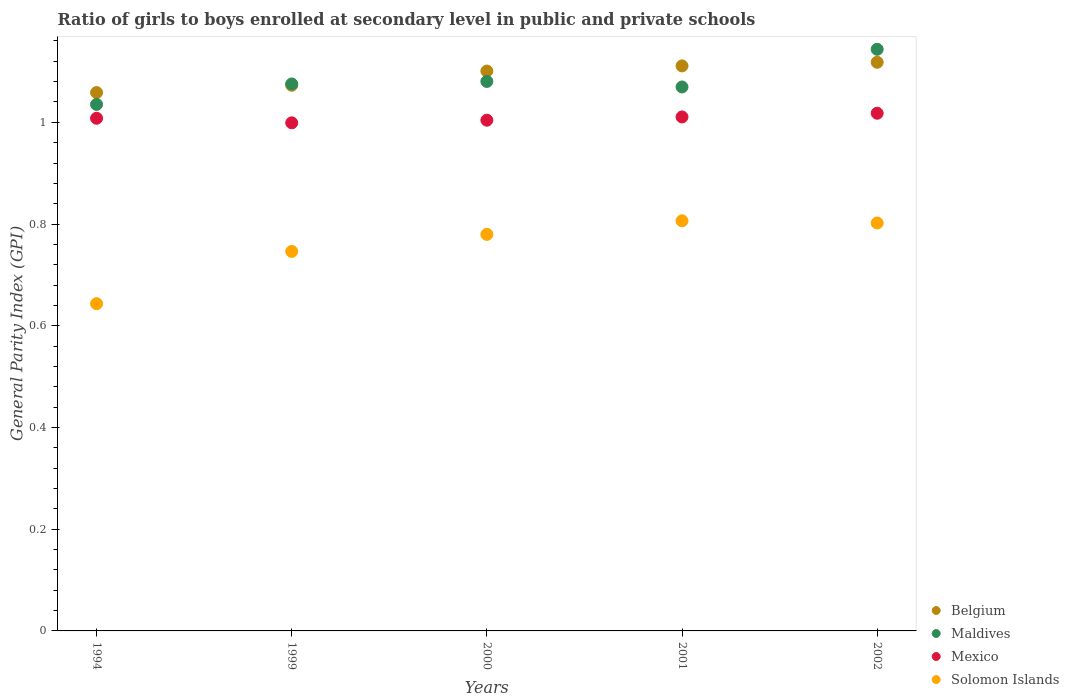Is the number of dotlines equal to the number of legend labels?
Your response must be concise. Yes. Across all years, what is the maximum general parity index in Mexico?
Offer a very short reply. 1.02. Across all years, what is the minimum general parity index in Maldives?
Provide a succinct answer. 1.04. In which year was the general parity index in Mexico maximum?
Provide a short and direct response. 2002. In which year was the general parity index in Solomon Islands minimum?
Make the answer very short. 1994. What is the total general parity index in Maldives in the graph?
Offer a very short reply. 5.4. What is the difference between the general parity index in Solomon Islands in 1994 and that in 2002?
Keep it short and to the point. -0.16. What is the difference between the general parity index in Belgium in 2002 and the general parity index in Mexico in 1999?
Make the answer very short. 0.12. What is the average general parity index in Belgium per year?
Ensure brevity in your answer.  1.09. In the year 2002, what is the difference between the general parity index in Belgium and general parity index in Solomon Islands?
Your response must be concise. 0.32. What is the ratio of the general parity index in Solomon Islands in 1999 to that in 2001?
Keep it short and to the point. 0.93. What is the difference between the highest and the second highest general parity index in Belgium?
Keep it short and to the point. 0.01. What is the difference between the highest and the lowest general parity index in Mexico?
Make the answer very short. 0.02. Is it the case that in every year, the sum of the general parity index in Mexico and general parity index in Maldives  is greater than the sum of general parity index in Solomon Islands and general parity index in Belgium?
Provide a succinct answer. Yes. Is the general parity index in Mexico strictly less than the general parity index in Belgium over the years?
Provide a succinct answer. Yes. How many years are there in the graph?
Offer a very short reply. 5. What is the difference between two consecutive major ticks on the Y-axis?
Your answer should be very brief. 0.2. Are the values on the major ticks of Y-axis written in scientific E-notation?
Ensure brevity in your answer.  No. Does the graph contain any zero values?
Ensure brevity in your answer.  No. Does the graph contain grids?
Offer a terse response. No. Where does the legend appear in the graph?
Offer a terse response. Bottom right. How many legend labels are there?
Your answer should be very brief. 4. How are the legend labels stacked?
Your response must be concise. Vertical. What is the title of the graph?
Keep it short and to the point. Ratio of girls to boys enrolled at secondary level in public and private schools. Does "Ecuador" appear as one of the legend labels in the graph?
Offer a very short reply. No. What is the label or title of the X-axis?
Give a very brief answer. Years. What is the label or title of the Y-axis?
Provide a succinct answer. General Parity Index (GPI). What is the General Parity Index (GPI) of Belgium in 1994?
Give a very brief answer. 1.06. What is the General Parity Index (GPI) in Maldives in 1994?
Offer a very short reply. 1.04. What is the General Parity Index (GPI) of Solomon Islands in 1994?
Offer a very short reply. 0.64. What is the General Parity Index (GPI) in Belgium in 1999?
Give a very brief answer. 1.07. What is the General Parity Index (GPI) of Maldives in 1999?
Provide a short and direct response. 1.08. What is the General Parity Index (GPI) in Mexico in 1999?
Ensure brevity in your answer.  1. What is the General Parity Index (GPI) of Solomon Islands in 1999?
Provide a succinct answer. 0.75. What is the General Parity Index (GPI) of Belgium in 2000?
Offer a very short reply. 1.1. What is the General Parity Index (GPI) of Maldives in 2000?
Your response must be concise. 1.08. What is the General Parity Index (GPI) of Mexico in 2000?
Provide a succinct answer. 1. What is the General Parity Index (GPI) in Solomon Islands in 2000?
Provide a short and direct response. 0.78. What is the General Parity Index (GPI) of Belgium in 2001?
Offer a very short reply. 1.11. What is the General Parity Index (GPI) in Maldives in 2001?
Your response must be concise. 1.07. What is the General Parity Index (GPI) in Mexico in 2001?
Your answer should be compact. 1.01. What is the General Parity Index (GPI) in Solomon Islands in 2001?
Make the answer very short. 0.81. What is the General Parity Index (GPI) in Belgium in 2002?
Provide a succinct answer. 1.12. What is the General Parity Index (GPI) in Maldives in 2002?
Your answer should be very brief. 1.14. What is the General Parity Index (GPI) of Mexico in 2002?
Provide a short and direct response. 1.02. What is the General Parity Index (GPI) in Solomon Islands in 2002?
Offer a very short reply. 0.8. Across all years, what is the maximum General Parity Index (GPI) in Belgium?
Your answer should be very brief. 1.12. Across all years, what is the maximum General Parity Index (GPI) of Maldives?
Offer a terse response. 1.14. Across all years, what is the maximum General Parity Index (GPI) in Mexico?
Provide a succinct answer. 1.02. Across all years, what is the maximum General Parity Index (GPI) of Solomon Islands?
Make the answer very short. 0.81. Across all years, what is the minimum General Parity Index (GPI) in Belgium?
Provide a short and direct response. 1.06. Across all years, what is the minimum General Parity Index (GPI) of Maldives?
Give a very brief answer. 1.04. Across all years, what is the minimum General Parity Index (GPI) in Mexico?
Offer a terse response. 1. Across all years, what is the minimum General Parity Index (GPI) of Solomon Islands?
Keep it short and to the point. 0.64. What is the total General Parity Index (GPI) in Belgium in the graph?
Keep it short and to the point. 5.46. What is the total General Parity Index (GPI) in Maldives in the graph?
Keep it short and to the point. 5.4. What is the total General Parity Index (GPI) of Mexico in the graph?
Give a very brief answer. 5.04. What is the total General Parity Index (GPI) of Solomon Islands in the graph?
Provide a short and direct response. 3.78. What is the difference between the General Parity Index (GPI) of Belgium in 1994 and that in 1999?
Your response must be concise. -0.01. What is the difference between the General Parity Index (GPI) of Maldives in 1994 and that in 1999?
Provide a short and direct response. -0.04. What is the difference between the General Parity Index (GPI) of Mexico in 1994 and that in 1999?
Your answer should be very brief. 0.01. What is the difference between the General Parity Index (GPI) of Solomon Islands in 1994 and that in 1999?
Keep it short and to the point. -0.1. What is the difference between the General Parity Index (GPI) of Belgium in 1994 and that in 2000?
Give a very brief answer. -0.04. What is the difference between the General Parity Index (GPI) in Maldives in 1994 and that in 2000?
Provide a succinct answer. -0.05. What is the difference between the General Parity Index (GPI) in Mexico in 1994 and that in 2000?
Offer a very short reply. 0. What is the difference between the General Parity Index (GPI) of Solomon Islands in 1994 and that in 2000?
Keep it short and to the point. -0.14. What is the difference between the General Parity Index (GPI) of Belgium in 1994 and that in 2001?
Keep it short and to the point. -0.05. What is the difference between the General Parity Index (GPI) of Maldives in 1994 and that in 2001?
Give a very brief answer. -0.03. What is the difference between the General Parity Index (GPI) in Mexico in 1994 and that in 2001?
Offer a very short reply. -0. What is the difference between the General Parity Index (GPI) of Solomon Islands in 1994 and that in 2001?
Offer a very short reply. -0.16. What is the difference between the General Parity Index (GPI) in Belgium in 1994 and that in 2002?
Your response must be concise. -0.06. What is the difference between the General Parity Index (GPI) in Maldives in 1994 and that in 2002?
Provide a succinct answer. -0.11. What is the difference between the General Parity Index (GPI) of Mexico in 1994 and that in 2002?
Your answer should be very brief. -0.01. What is the difference between the General Parity Index (GPI) in Solomon Islands in 1994 and that in 2002?
Make the answer very short. -0.16. What is the difference between the General Parity Index (GPI) of Belgium in 1999 and that in 2000?
Your answer should be compact. -0.03. What is the difference between the General Parity Index (GPI) in Maldives in 1999 and that in 2000?
Offer a very short reply. -0. What is the difference between the General Parity Index (GPI) in Mexico in 1999 and that in 2000?
Offer a very short reply. -0.01. What is the difference between the General Parity Index (GPI) in Solomon Islands in 1999 and that in 2000?
Make the answer very short. -0.03. What is the difference between the General Parity Index (GPI) in Belgium in 1999 and that in 2001?
Give a very brief answer. -0.04. What is the difference between the General Parity Index (GPI) in Maldives in 1999 and that in 2001?
Make the answer very short. 0.01. What is the difference between the General Parity Index (GPI) in Mexico in 1999 and that in 2001?
Provide a short and direct response. -0.01. What is the difference between the General Parity Index (GPI) of Solomon Islands in 1999 and that in 2001?
Ensure brevity in your answer.  -0.06. What is the difference between the General Parity Index (GPI) in Belgium in 1999 and that in 2002?
Provide a succinct answer. -0.05. What is the difference between the General Parity Index (GPI) of Maldives in 1999 and that in 2002?
Offer a very short reply. -0.07. What is the difference between the General Parity Index (GPI) in Mexico in 1999 and that in 2002?
Provide a succinct answer. -0.02. What is the difference between the General Parity Index (GPI) in Solomon Islands in 1999 and that in 2002?
Offer a terse response. -0.06. What is the difference between the General Parity Index (GPI) of Belgium in 2000 and that in 2001?
Offer a very short reply. -0.01. What is the difference between the General Parity Index (GPI) of Maldives in 2000 and that in 2001?
Offer a very short reply. 0.01. What is the difference between the General Parity Index (GPI) in Mexico in 2000 and that in 2001?
Provide a short and direct response. -0.01. What is the difference between the General Parity Index (GPI) in Solomon Islands in 2000 and that in 2001?
Your response must be concise. -0.03. What is the difference between the General Parity Index (GPI) of Belgium in 2000 and that in 2002?
Your answer should be very brief. -0.02. What is the difference between the General Parity Index (GPI) of Maldives in 2000 and that in 2002?
Keep it short and to the point. -0.06. What is the difference between the General Parity Index (GPI) in Mexico in 2000 and that in 2002?
Provide a succinct answer. -0.01. What is the difference between the General Parity Index (GPI) in Solomon Islands in 2000 and that in 2002?
Offer a terse response. -0.02. What is the difference between the General Parity Index (GPI) of Belgium in 2001 and that in 2002?
Give a very brief answer. -0.01. What is the difference between the General Parity Index (GPI) of Maldives in 2001 and that in 2002?
Provide a short and direct response. -0.07. What is the difference between the General Parity Index (GPI) in Mexico in 2001 and that in 2002?
Provide a succinct answer. -0.01. What is the difference between the General Parity Index (GPI) in Solomon Islands in 2001 and that in 2002?
Offer a terse response. 0. What is the difference between the General Parity Index (GPI) of Belgium in 1994 and the General Parity Index (GPI) of Maldives in 1999?
Ensure brevity in your answer.  -0.02. What is the difference between the General Parity Index (GPI) in Belgium in 1994 and the General Parity Index (GPI) in Mexico in 1999?
Keep it short and to the point. 0.06. What is the difference between the General Parity Index (GPI) of Belgium in 1994 and the General Parity Index (GPI) of Solomon Islands in 1999?
Provide a short and direct response. 0.31. What is the difference between the General Parity Index (GPI) in Maldives in 1994 and the General Parity Index (GPI) in Mexico in 1999?
Provide a short and direct response. 0.04. What is the difference between the General Parity Index (GPI) in Maldives in 1994 and the General Parity Index (GPI) in Solomon Islands in 1999?
Your answer should be very brief. 0.29. What is the difference between the General Parity Index (GPI) in Mexico in 1994 and the General Parity Index (GPI) in Solomon Islands in 1999?
Your answer should be very brief. 0.26. What is the difference between the General Parity Index (GPI) in Belgium in 1994 and the General Parity Index (GPI) in Maldives in 2000?
Your answer should be compact. -0.02. What is the difference between the General Parity Index (GPI) of Belgium in 1994 and the General Parity Index (GPI) of Mexico in 2000?
Provide a short and direct response. 0.05. What is the difference between the General Parity Index (GPI) in Belgium in 1994 and the General Parity Index (GPI) in Solomon Islands in 2000?
Ensure brevity in your answer.  0.28. What is the difference between the General Parity Index (GPI) in Maldives in 1994 and the General Parity Index (GPI) in Mexico in 2000?
Your answer should be compact. 0.03. What is the difference between the General Parity Index (GPI) of Maldives in 1994 and the General Parity Index (GPI) of Solomon Islands in 2000?
Keep it short and to the point. 0.26. What is the difference between the General Parity Index (GPI) of Mexico in 1994 and the General Parity Index (GPI) of Solomon Islands in 2000?
Offer a very short reply. 0.23. What is the difference between the General Parity Index (GPI) of Belgium in 1994 and the General Parity Index (GPI) of Maldives in 2001?
Give a very brief answer. -0.01. What is the difference between the General Parity Index (GPI) of Belgium in 1994 and the General Parity Index (GPI) of Mexico in 2001?
Your answer should be very brief. 0.05. What is the difference between the General Parity Index (GPI) in Belgium in 1994 and the General Parity Index (GPI) in Solomon Islands in 2001?
Your answer should be compact. 0.25. What is the difference between the General Parity Index (GPI) in Maldives in 1994 and the General Parity Index (GPI) in Mexico in 2001?
Your answer should be compact. 0.02. What is the difference between the General Parity Index (GPI) in Maldives in 1994 and the General Parity Index (GPI) in Solomon Islands in 2001?
Provide a succinct answer. 0.23. What is the difference between the General Parity Index (GPI) in Mexico in 1994 and the General Parity Index (GPI) in Solomon Islands in 2001?
Your answer should be compact. 0.2. What is the difference between the General Parity Index (GPI) in Belgium in 1994 and the General Parity Index (GPI) in Maldives in 2002?
Ensure brevity in your answer.  -0.09. What is the difference between the General Parity Index (GPI) of Belgium in 1994 and the General Parity Index (GPI) of Mexico in 2002?
Keep it short and to the point. 0.04. What is the difference between the General Parity Index (GPI) in Belgium in 1994 and the General Parity Index (GPI) in Solomon Islands in 2002?
Keep it short and to the point. 0.26. What is the difference between the General Parity Index (GPI) in Maldives in 1994 and the General Parity Index (GPI) in Mexico in 2002?
Offer a terse response. 0.02. What is the difference between the General Parity Index (GPI) in Maldives in 1994 and the General Parity Index (GPI) in Solomon Islands in 2002?
Your answer should be compact. 0.23. What is the difference between the General Parity Index (GPI) in Mexico in 1994 and the General Parity Index (GPI) in Solomon Islands in 2002?
Provide a succinct answer. 0.21. What is the difference between the General Parity Index (GPI) in Belgium in 1999 and the General Parity Index (GPI) in Maldives in 2000?
Provide a succinct answer. -0.01. What is the difference between the General Parity Index (GPI) of Belgium in 1999 and the General Parity Index (GPI) of Mexico in 2000?
Offer a very short reply. 0.07. What is the difference between the General Parity Index (GPI) of Belgium in 1999 and the General Parity Index (GPI) of Solomon Islands in 2000?
Your response must be concise. 0.29. What is the difference between the General Parity Index (GPI) of Maldives in 1999 and the General Parity Index (GPI) of Mexico in 2000?
Your answer should be very brief. 0.07. What is the difference between the General Parity Index (GPI) of Maldives in 1999 and the General Parity Index (GPI) of Solomon Islands in 2000?
Give a very brief answer. 0.3. What is the difference between the General Parity Index (GPI) of Mexico in 1999 and the General Parity Index (GPI) of Solomon Islands in 2000?
Make the answer very short. 0.22. What is the difference between the General Parity Index (GPI) of Belgium in 1999 and the General Parity Index (GPI) of Maldives in 2001?
Keep it short and to the point. 0. What is the difference between the General Parity Index (GPI) of Belgium in 1999 and the General Parity Index (GPI) of Mexico in 2001?
Keep it short and to the point. 0.06. What is the difference between the General Parity Index (GPI) in Belgium in 1999 and the General Parity Index (GPI) in Solomon Islands in 2001?
Your answer should be very brief. 0.27. What is the difference between the General Parity Index (GPI) in Maldives in 1999 and the General Parity Index (GPI) in Mexico in 2001?
Provide a short and direct response. 0.06. What is the difference between the General Parity Index (GPI) in Maldives in 1999 and the General Parity Index (GPI) in Solomon Islands in 2001?
Offer a terse response. 0.27. What is the difference between the General Parity Index (GPI) of Mexico in 1999 and the General Parity Index (GPI) of Solomon Islands in 2001?
Your answer should be very brief. 0.19. What is the difference between the General Parity Index (GPI) of Belgium in 1999 and the General Parity Index (GPI) of Maldives in 2002?
Your response must be concise. -0.07. What is the difference between the General Parity Index (GPI) of Belgium in 1999 and the General Parity Index (GPI) of Mexico in 2002?
Give a very brief answer. 0.06. What is the difference between the General Parity Index (GPI) in Belgium in 1999 and the General Parity Index (GPI) in Solomon Islands in 2002?
Your response must be concise. 0.27. What is the difference between the General Parity Index (GPI) in Maldives in 1999 and the General Parity Index (GPI) in Mexico in 2002?
Give a very brief answer. 0.06. What is the difference between the General Parity Index (GPI) of Maldives in 1999 and the General Parity Index (GPI) of Solomon Islands in 2002?
Ensure brevity in your answer.  0.27. What is the difference between the General Parity Index (GPI) in Mexico in 1999 and the General Parity Index (GPI) in Solomon Islands in 2002?
Ensure brevity in your answer.  0.2. What is the difference between the General Parity Index (GPI) of Belgium in 2000 and the General Parity Index (GPI) of Maldives in 2001?
Your answer should be compact. 0.03. What is the difference between the General Parity Index (GPI) in Belgium in 2000 and the General Parity Index (GPI) in Mexico in 2001?
Ensure brevity in your answer.  0.09. What is the difference between the General Parity Index (GPI) in Belgium in 2000 and the General Parity Index (GPI) in Solomon Islands in 2001?
Provide a succinct answer. 0.29. What is the difference between the General Parity Index (GPI) in Maldives in 2000 and the General Parity Index (GPI) in Mexico in 2001?
Your answer should be very brief. 0.07. What is the difference between the General Parity Index (GPI) of Maldives in 2000 and the General Parity Index (GPI) of Solomon Islands in 2001?
Provide a succinct answer. 0.27. What is the difference between the General Parity Index (GPI) in Mexico in 2000 and the General Parity Index (GPI) in Solomon Islands in 2001?
Make the answer very short. 0.2. What is the difference between the General Parity Index (GPI) of Belgium in 2000 and the General Parity Index (GPI) of Maldives in 2002?
Offer a very short reply. -0.04. What is the difference between the General Parity Index (GPI) in Belgium in 2000 and the General Parity Index (GPI) in Mexico in 2002?
Offer a very short reply. 0.08. What is the difference between the General Parity Index (GPI) of Belgium in 2000 and the General Parity Index (GPI) of Solomon Islands in 2002?
Provide a succinct answer. 0.3. What is the difference between the General Parity Index (GPI) of Maldives in 2000 and the General Parity Index (GPI) of Mexico in 2002?
Your answer should be compact. 0.06. What is the difference between the General Parity Index (GPI) of Maldives in 2000 and the General Parity Index (GPI) of Solomon Islands in 2002?
Your answer should be compact. 0.28. What is the difference between the General Parity Index (GPI) of Mexico in 2000 and the General Parity Index (GPI) of Solomon Islands in 2002?
Your answer should be compact. 0.2. What is the difference between the General Parity Index (GPI) of Belgium in 2001 and the General Parity Index (GPI) of Maldives in 2002?
Give a very brief answer. -0.03. What is the difference between the General Parity Index (GPI) in Belgium in 2001 and the General Parity Index (GPI) in Mexico in 2002?
Your answer should be compact. 0.09. What is the difference between the General Parity Index (GPI) of Belgium in 2001 and the General Parity Index (GPI) of Solomon Islands in 2002?
Give a very brief answer. 0.31. What is the difference between the General Parity Index (GPI) of Maldives in 2001 and the General Parity Index (GPI) of Mexico in 2002?
Provide a succinct answer. 0.05. What is the difference between the General Parity Index (GPI) in Maldives in 2001 and the General Parity Index (GPI) in Solomon Islands in 2002?
Keep it short and to the point. 0.27. What is the difference between the General Parity Index (GPI) in Mexico in 2001 and the General Parity Index (GPI) in Solomon Islands in 2002?
Provide a short and direct response. 0.21. What is the average General Parity Index (GPI) in Belgium per year?
Give a very brief answer. 1.09. What is the average General Parity Index (GPI) in Maldives per year?
Ensure brevity in your answer.  1.08. What is the average General Parity Index (GPI) in Mexico per year?
Your answer should be very brief. 1.01. What is the average General Parity Index (GPI) in Solomon Islands per year?
Give a very brief answer. 0.76. In the year 1994, what is the difference between the General Parity Index (GPI) in Belgium and General Parity Index (GPI) in Maldives?
Give a very brief answer. 0.02. In the year 1994, what is the difference between the General Parity Index (GPI) in Belgium and General Parity Index (GPI) in Mexico?
Make the answer very short. 0.05. In the year 1994, what is the difference between the General Parity Index (GPI) in Belgium and General Parity Index (GPI) in Solomon Islands?
Make the answer very short. 0.42. In the year 1994, what is the difference between the General Parity Index (GPI) in Maldives and General Parity Index (GPI) in Mexico?
Make the answer very short. 0.03. In the year 1994, what is the difference between the General Parity Index (GPI) in Maldives and General Parity Index (GPI) in Solomon Islands?
Your answer should be very brief. 0.39. In the year 1994, what is the difference between the General Parity Index (GPI) in Mexico and General Parity Index (GPI) in Solomon Islands?
Your answer should be very brief. 0.36. In the year 1999, what is the difference between the General Parity Index (GPI) of Belgium and General Parity Index (GPI) of Maldives?
Offer a very short reply. -0. In the year 1999, what is the difference between the General Parity Index (GPI) in Belgium and General Parity Index (GPI) in Mexico?
Give a very brief answer. 0.07. In the year 1999, what is the difference between the General Parity Index (GPI) in Belgium and General Parity Index (GPI) in Solomon Islands?
Give a very brief answer. 0.33. In the year 1999, what is the difference between the General Parity Index (GPI) of Maldives and General Parity Index (GPI) of Mexico?
Your answer should be very brief. 0.08. In the year 1999, what is the difference between the General Parity Index (GPI) of Maldives and General Parity Index (GPI) of Solomon Islands?
Offer a terse response. 0.33. In the year 1999, what is the difference between the General Parity Index (GPI) in Mexico and General Parity Index (GPI) in Solomon Islands?
Ensure brevity in your answer.  0.25. In the year 2000, what is the difference between the General Parity Index (GPI) of Belgium and General Parity Index (GPI) of Maldives?
Your response must be concise. 0.02. In the year 2000, what is the difference between the General Parity Index (GPI) in Belgium and General Parity Index (GPI) in Mexico?
Provide a succinct answer. 0.1. In the year 2000, what is the difference between the General Parity Index (GPI) of Belgium and General Parity Index (GPI) of Solomon Islands?
Keep it short and to the point. 0.32. In the year 2000, what is the difference between the General Parity Index (GPI) of Maldives and General Parity Index (GPI) of Mexico?
Ensure brevity in your answer.  0.08. In the year 2000, what is the difference between the General Parity Index (GPI) in Maldives and General Parity Index (GPI) in Solomon Islands?
Your response must be concise. 0.3. In the year 2000, what is the difference between the General Parity Index (GPI) of Mexico and General Parity Index (GPI) of Solomon Islands?
Offer a very short reply. 0.22. In the year 2001, what is the difference between the General Parity Index (GPI) of Belgium and General Parity Index (GPI) of Maldives?
Offer a very short reply. 0.04. In the year 2001, what is the difference between the General Parity Index (GPI) in Belgium and General Parity Index (GPI) in Mexico?
Provide a short and direct response. 0.1. In the year 2001, what is the difference between the General Parity Index (GPI) in Belgium and General Parity Index (GPI) in Solomon Islands?
Offer a very short reply. 0.3. In the year 2001, what is the difference between the General Parity Index (GPI) of Maldives and General Parity Index (GPI) of Mexico?
Make the answer very short. 0.06. In the year 2001, what is the difference between the General Parity Index (GPI) in Maldives and General Parity Index (GPI) in Solomon Islands?
Keep it short and to the point. 0.26. In the year 2001, what is the difference between the General Parity Index (GPI) of Mexico and General Parity Index (GPI) of Solomon Islands?
Keep it short and to the point. 0.2. In the year 2002, what is the difference between the General Parity Index (GPI) of Belgium and General Parity Index (GPI) of Maldives?
Offer a terse response. -0.03. In the year 2002, what is the difference between the General Parity Index (GPI) of Belgium and General Parity Index (GPI) of Mexico?
Provide a succinct answer. 0.1. In the year 2002, what is the difference between the General Parity Index (GPI) in Belgium and General Parity Index (GPI) in Solomon Islands?
Your answer should be compact. 0.32. In the year 2002, what is the difference between the General Parity Index (GPI) in Maldives and General Parity Index (GPI) in Mexico?
Make the answer very short. 0.13. In the year 2002, what is the difference between the General Parity Index (GPI) in Maldives and General Parity Index (GPI) in Solomon Islands?
Offer a terse response. 0.34. In the year 2002, what is the difference between the General Parity Index (GPI) in Mexico and General Parity Index (GPI) in Solomon Islands?
Offer a terse response. 0.22. What is the ratio of the General Parity Index (GPI) in Belgium in 1994 to that in 1999?
Offer a very short reply. 0.99. What is the ratio of the General Parity Index (GPI) of Maldives in 1994 to that in 1999?
Give a very brief answer. 0.96. What is the ratio of the General Parity Index (GPI) of Solomon Islands in 1994 to that in 1999?
Provide a short and direct response. 0.86. What is the ratio of the General Parity Index (GPI) in Belgium in 1994 to that in 2000?
Provide a succinct answer. 0.96. What is the ratio of the General Parity Index (GPI) in Maldives in 1994 to that in 2000?
Give a very brief answer. 0.96. What is the ratio of the General Parity Index (GPI) in Solomon Islands in 1994 to that in 2000?
Provide a succinct answer. 0.83. What is the ratio of the General Parity Index (GPI) of Belgium in 1994 to that in 2001?
Offer a very short reply. 0.95. What is the ratio of the General Parity Index (GPI) of Maldives in 1994 to that in 2001?
Provide a short and direct response. 0.97. What is the ratio of the General Parity Index (GPI) of Solomon Islands in 1994 to that in 2001?
Offer a terse response. 0.8. What is the ratio of the General Parity Index (GPI) in Belgium in 1994 to that in 2002?
Provide a succinct answer. 0.95. What is the ratio of the General Parity Index (GPI) of Maldives in 1994 to that in 2002?
Your response must be concise. 0.91. What is the ratio of the General Parity Index (GPI) of Mexico in 1994 to that in 2002?
Your answer should be very brief. 0.99. What is the ratio of the General Parity Index (GPI) of Solomon Islands in 1994 to that in 2002?
Offer a very short reply. 0.8. What is the ratio of the General Parity Index (GPI) of Belgium in 1999 to that in 2000?
Keep it short and to the point. 0.97. What is the ratio of the General Parity Index (GPI) in Mexico in 1999 to that in 2000?
Your answer should be very brief. 0.99. What is the ratio of the General Parity Index (GPI) in Solomon Islands in 1999 to that in 2000?
Offer a terse response. 0.96. What is the ratio of the General Parity Index (GPI) of Belgium in 1999 to that in 2001?
Offer a very short reply. 0.97. What is the ratio of the General Parity Index (GPI) in Maldives in 1999 to that in 2001?
Make the answer very short. 1.01. What is the ratio of the General Parity Index (GPI) of Mexico in 1999 to that in 2001?
Offer a terse response. 0.99. What is the ratio of the General Parity Index (GPI) of Solomon Islands in 1999 to that in 2001?
Make the answer very short. 0.93. What is the ratio of the General Parity Index (GPI) in Belgium in 1999 to that in 2002?
Offer a terse response. 0.96. What is the ratio of the General Parity Index (GPI) in Maldives in 1999 to that in 2002?
Your answer should be very brief. 0.94. What is the ratio of the General Parity Index (GPI) in Mexico in 1999 to that in 2002?
Offer a very short reply. 0.98. What is the ratio of the General Parity Index (GPI) in Solomon Islands in 1999 to that in 2002?
Make the answer very short. 0.93. What is the ratio of the General Parity Index (GPI) in Belgium in 2000 to that in 2001?
Your answer should be compact. 0.99. What is the ratio of the General Parity Index (GPI) in Maldives in 2000 to that in 2001?
Offer a very short reply. 1.01. What is the ratio of the General Parity Index (GPI) in Solomon Islands in 2000 to that in 2001?
Give a very brief answer. 0.97. What is the ratio of the General Parity Index (GPI) of Belgium in 2000 to that in 2002?
Make the answer very short. 0.98. What is the ratio of the General Parity Index (GPI) of Maldives in 2000 to that in 2002?
Provide a short and direct response. 0.94. What is the ratio of the General Parity Index (GPI) in Mexico in 2000 to that in 2002?
Ensure brevity in your answer.  0.99. What is the ratio of the General Parity Index (GPI) in Solomon Islands in 2000 to that in 2002?
Give a very brief answer. 0.97. What is the ratio of the General Parity Index (GPI) of Belgium in 2001 to that in 2002?
Ensure brevity in your answer.  0.99. What is the ratio of the General Parity Index (GPI) in Maldives in 2001 to that in 2002?
Offer a very short reply. 0.94. What is the ratio of the General Parity Index (GPI) in Solomon Islands in 2001 to that in 2002?
Keep it short and to the point. 1.01. What is the difference between the highest and the second highest General Parity Index (GPI) in Belgium?
Give a very brief answer. 0.01. What is the difference between the highest and the second highest General Parity Index (GPI) of Maldives?
Ensure brevity in your answer.  0.06. What is the difference between the highest and the second highest General Parity Index (GPI) in Mexico?
Provide a short and direct response. 0.01. What is the difference between the highest and the second highest General Parity Index (GPI) of Solomon Islands?
Provide a succinct answer. 0. What is the difference between the highest and the lowest General Parity Index (GPI) of Belgium?
Provide a succinct answer. 0.06. What is the difference between the highest and the lowest General Parity Index (GPI) in Maldives?
Offer a terse response. 0.11. What is the difference between the highest and the lowest General Parity Index (GPI) in Mexico?
Give a very brief answer. 0.02. What is the difference between the highest and the lowest General Parity Index (GPI) in Solomon Islands?
Ensure brevity in your answer.  0.16. 